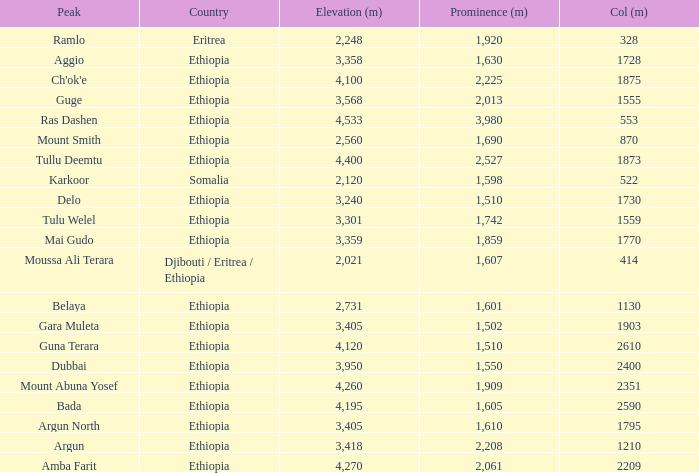What is the total prominence number in m of ethiopia, which has a col in m of 1728 and an elevation less than 3,358? 0.0. 